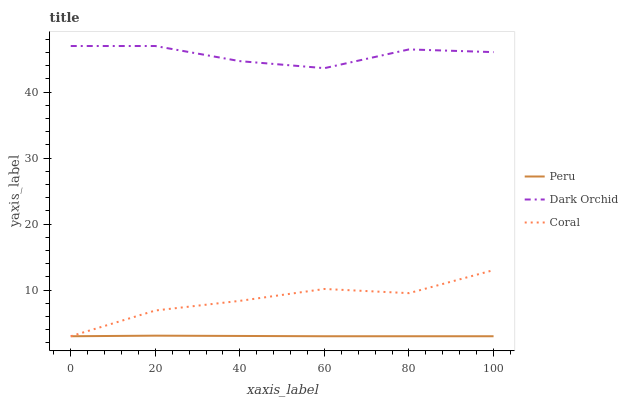Does Peru have the minimum area under the curve?
Answer yes or no. Yes. Does Dark Orchid have the maximum area under the curve?
Answer yes or no. Yes. Does Dark Orchid have the minimum area under the curve?
Answer yes or no. No. Does Peru have the maximum area under the curve?
Answer yes or no. No. Is Peru the smoothest?
Answer yes or no. Yes. Is Dark Orchid the roughest?
Answer yes or no. Yes. Is Dark Orchid the smoothest?
Answer yes or no. No. Is Peru the roughest?
Answer yes or no. No. Does Coral have the lowest value?
Answer yes or no. Yes. Does Dark Orchid have the lowest value?
Answer yes or no. No. Does Dark Orchid have the highest value?
Answer yes or no. Yes. Does Peru have the highest value?
Answer yes or no. No. Is Peru less than Dark Orchid?
Answer yes or no. Yes. Is Dark Orchid greater than Coral?
Answer yes or no. Yes. Does Coral intersect Peru?
Answer yes or no. Yes. Is Coral less than Peru?
Answer yes or no. No. Is Coral greater than Peru?
Answer yes or no. No. Does Peru intersect Dark Orchid?
Answer yes or no. No. 